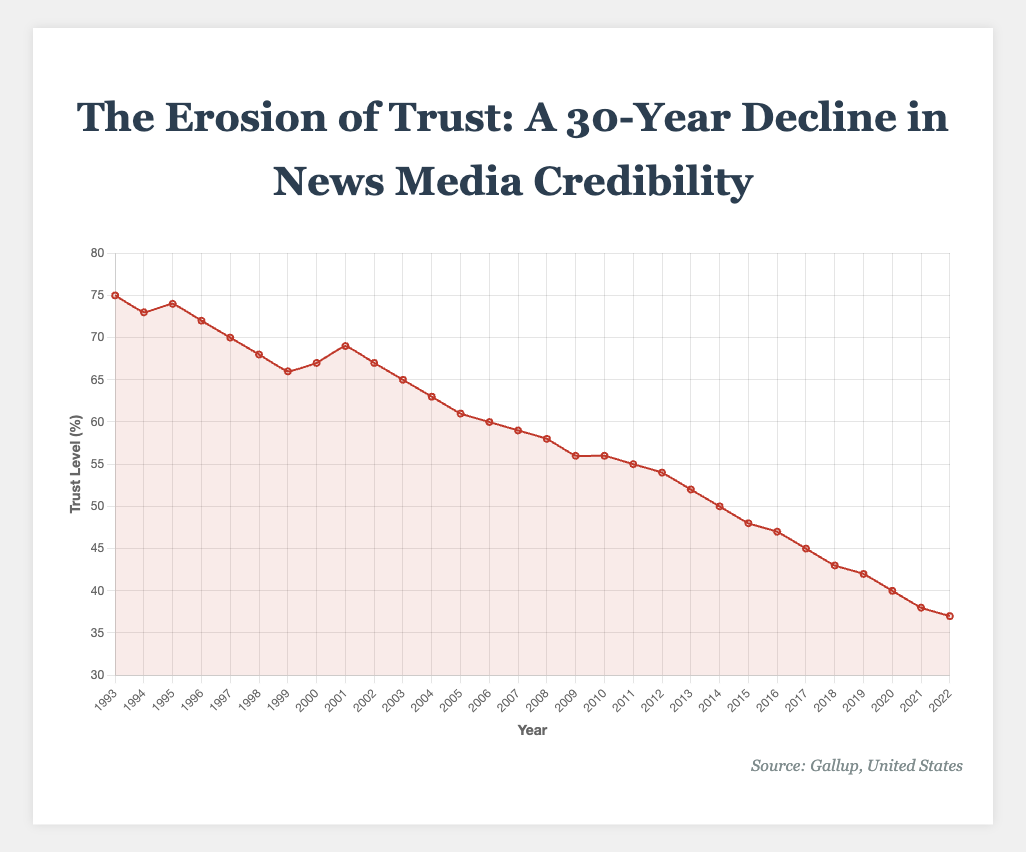What is the overall trend in public trust in news media from 1993 to 2022? The figure shows a consistent decline in public trust in news media over the period. Starting at 75% in 1993, the trust level falls progressively to 37% in 2022.
Answer: Decline What was the highest level of trust recorded and in which year? According to the figure, the highest level of trust was 75% in 1993. You can see the highest point in the line plot at the leftmost end on the Y-axis.
Answer: 75% in 1993 What was the lowest level of trust recorded and in which year? The figure indicates that the lowest level of trust was 37% in 2022. This can be seen at the rightmost end of the line plot.
Answer: 37% in 2022 Which year experienced a noticeable increase in trust following a decline? There was a noticeable increase in trust from 2000 to 2001, where the trust level rose from 67% to 69%. This is observed as a small upward spike in the generally declining trend.
Answer: 2001 Compare the trust levels between the years 2003 and 2022. How much did trust decrease by? In 2003, the trust level was 65%. By 2022, it had decreased to 37%. The difference in trust is calculated as 65% - 37% = 28%.
Answer: 28% What is the average trust level over the 30-year period? To calculate the average trust level, sum all the trust values and divide by the number of years: (75 + 73 + 74 + 72 + ... + 37) / 30. Summing these values gives 1563, and dividing by 30 gives 52.1%.
Answer: 52.1% In which decade was the decline in trust most steep? Observing the slope of the line plot, the steepest decline appears after around 2010, indicating the decade between 2010 and 2020 as the period with the most significant decline.
Answer: 2010-2020 What is the difference in trust levels between the start and end of the 1990s? At the start of the 1990s in 1993, trust was 75%. At the end of the decade in 1999, trust was 66%. The difference is 75% - 66% = 9%.
Answer: 9% At what approximate rate did trust decline per year from 1993 to 2022? The total decline over 30 years is 75% - 37% = 38%. The average annual decline can be calculated as 38% divided by 29 years (since decline is from 1993 to 2022), which gives approximately 1.31% per year.
Answer: 1.31% per year 